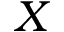<formula> <loc_0><loc_0><loc_500><loc_500>X</formula> 